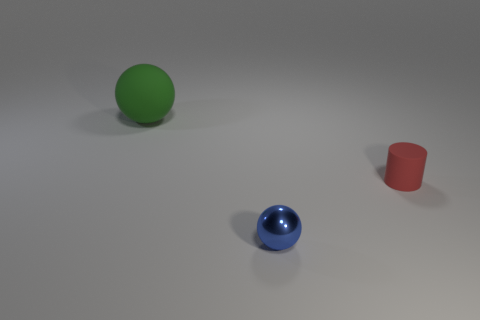Add 1 small red shiny blocks. How many objects exist? 4 Subtract all cylinders. How many objects are left? 2 Add 3 red matte things. How many red matte things are left? 4 Add 1 tiny things. How many tiny things exist? 3 Subtract 0 red balls. How many objects are left? 3 Subtract all rubber things. Subtract all small cyan rubber cylinders. How many objects are left? 1 